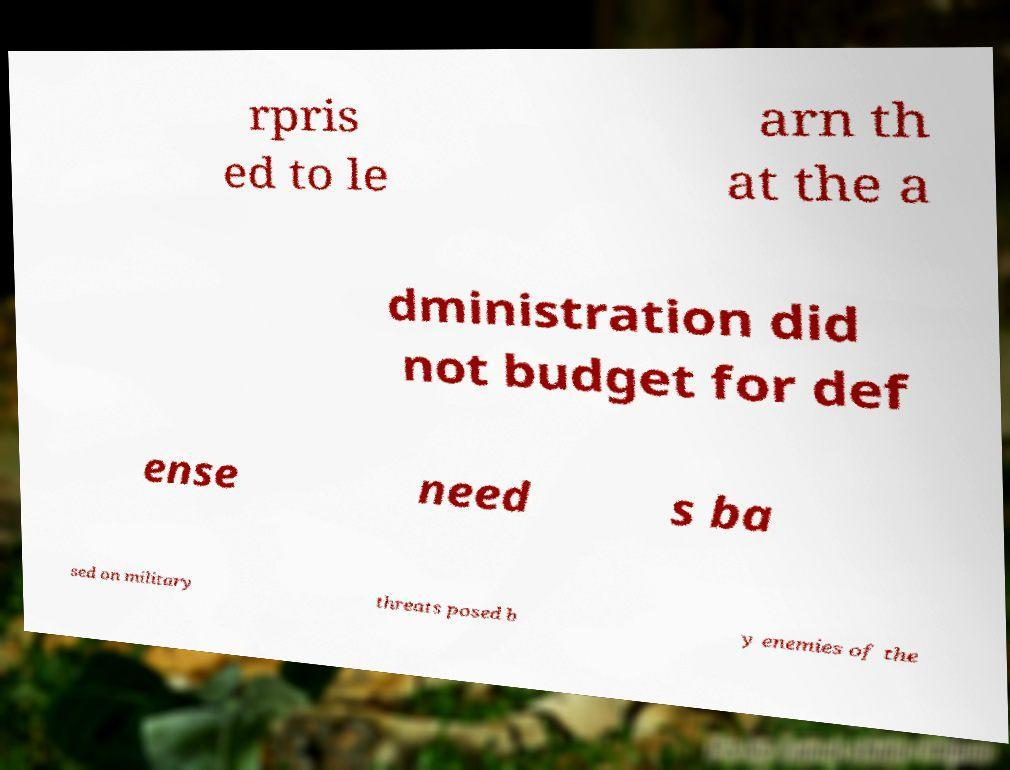I need the written content from this picture converted into text. Can you do that? rpris ed to le arn th at the a dministration did not budget for def ense need s ba sed on military threats posed b y enemies of the 